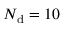Convert formula to latex. <formula><loc_0><loc_0><loc_500><loc_500>N _ { d } = 1 0</formula> 